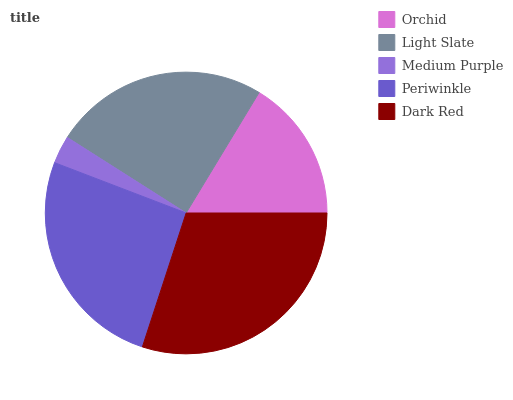Is Medium Purple the minimum?
Answer yes or no. Yes. Is Dark Red the maximum?
Answer yes or no. Yes. Is Light Slate the minimum?
Answer yes or no. No. Is Light Slate the maximum?
Answer yes or no. No. Is Light Slate greater than Orchid?
Answer yes or no. Yes. Is Orchid less than Light Slate?
Answer yes or no. Yes. Is Orchid greater than Light Slate?
Answer yes or no. No. Is Light Slate less than Orchid?
Answer yes or no. No. Is Light Slate the high median?
Answer yes or no. Yes. Is Light Slate the low median?
Answer yes or no. Yes. Is Medium Purple the high median?
Answer yes or no. No. Is Medium Purple the low median?
Answer yes or no. No. 